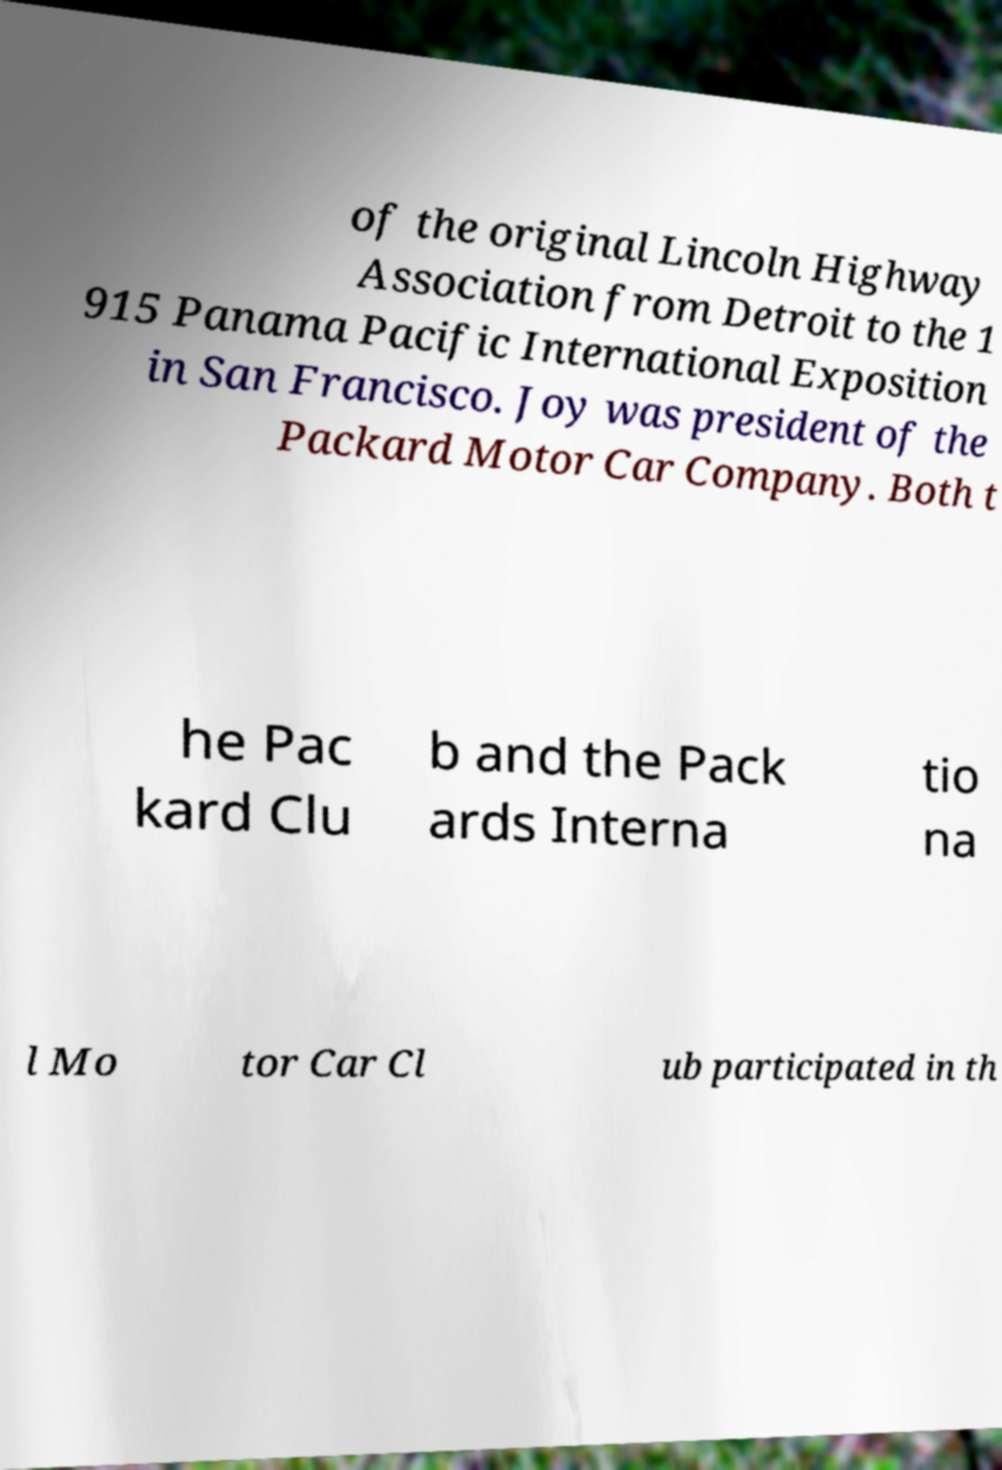Please identify and transcribe the text found in this image. of the original Lincoln Highway Association from Detroit to the 1 915 Panama Pacific International Exposition in San Francisco. Joy was president of the Packard Motor Car Company. Both t he Pac kard Clu b and the Pack ards Interna tio na l Mo tor Car Cl ub participated in th 